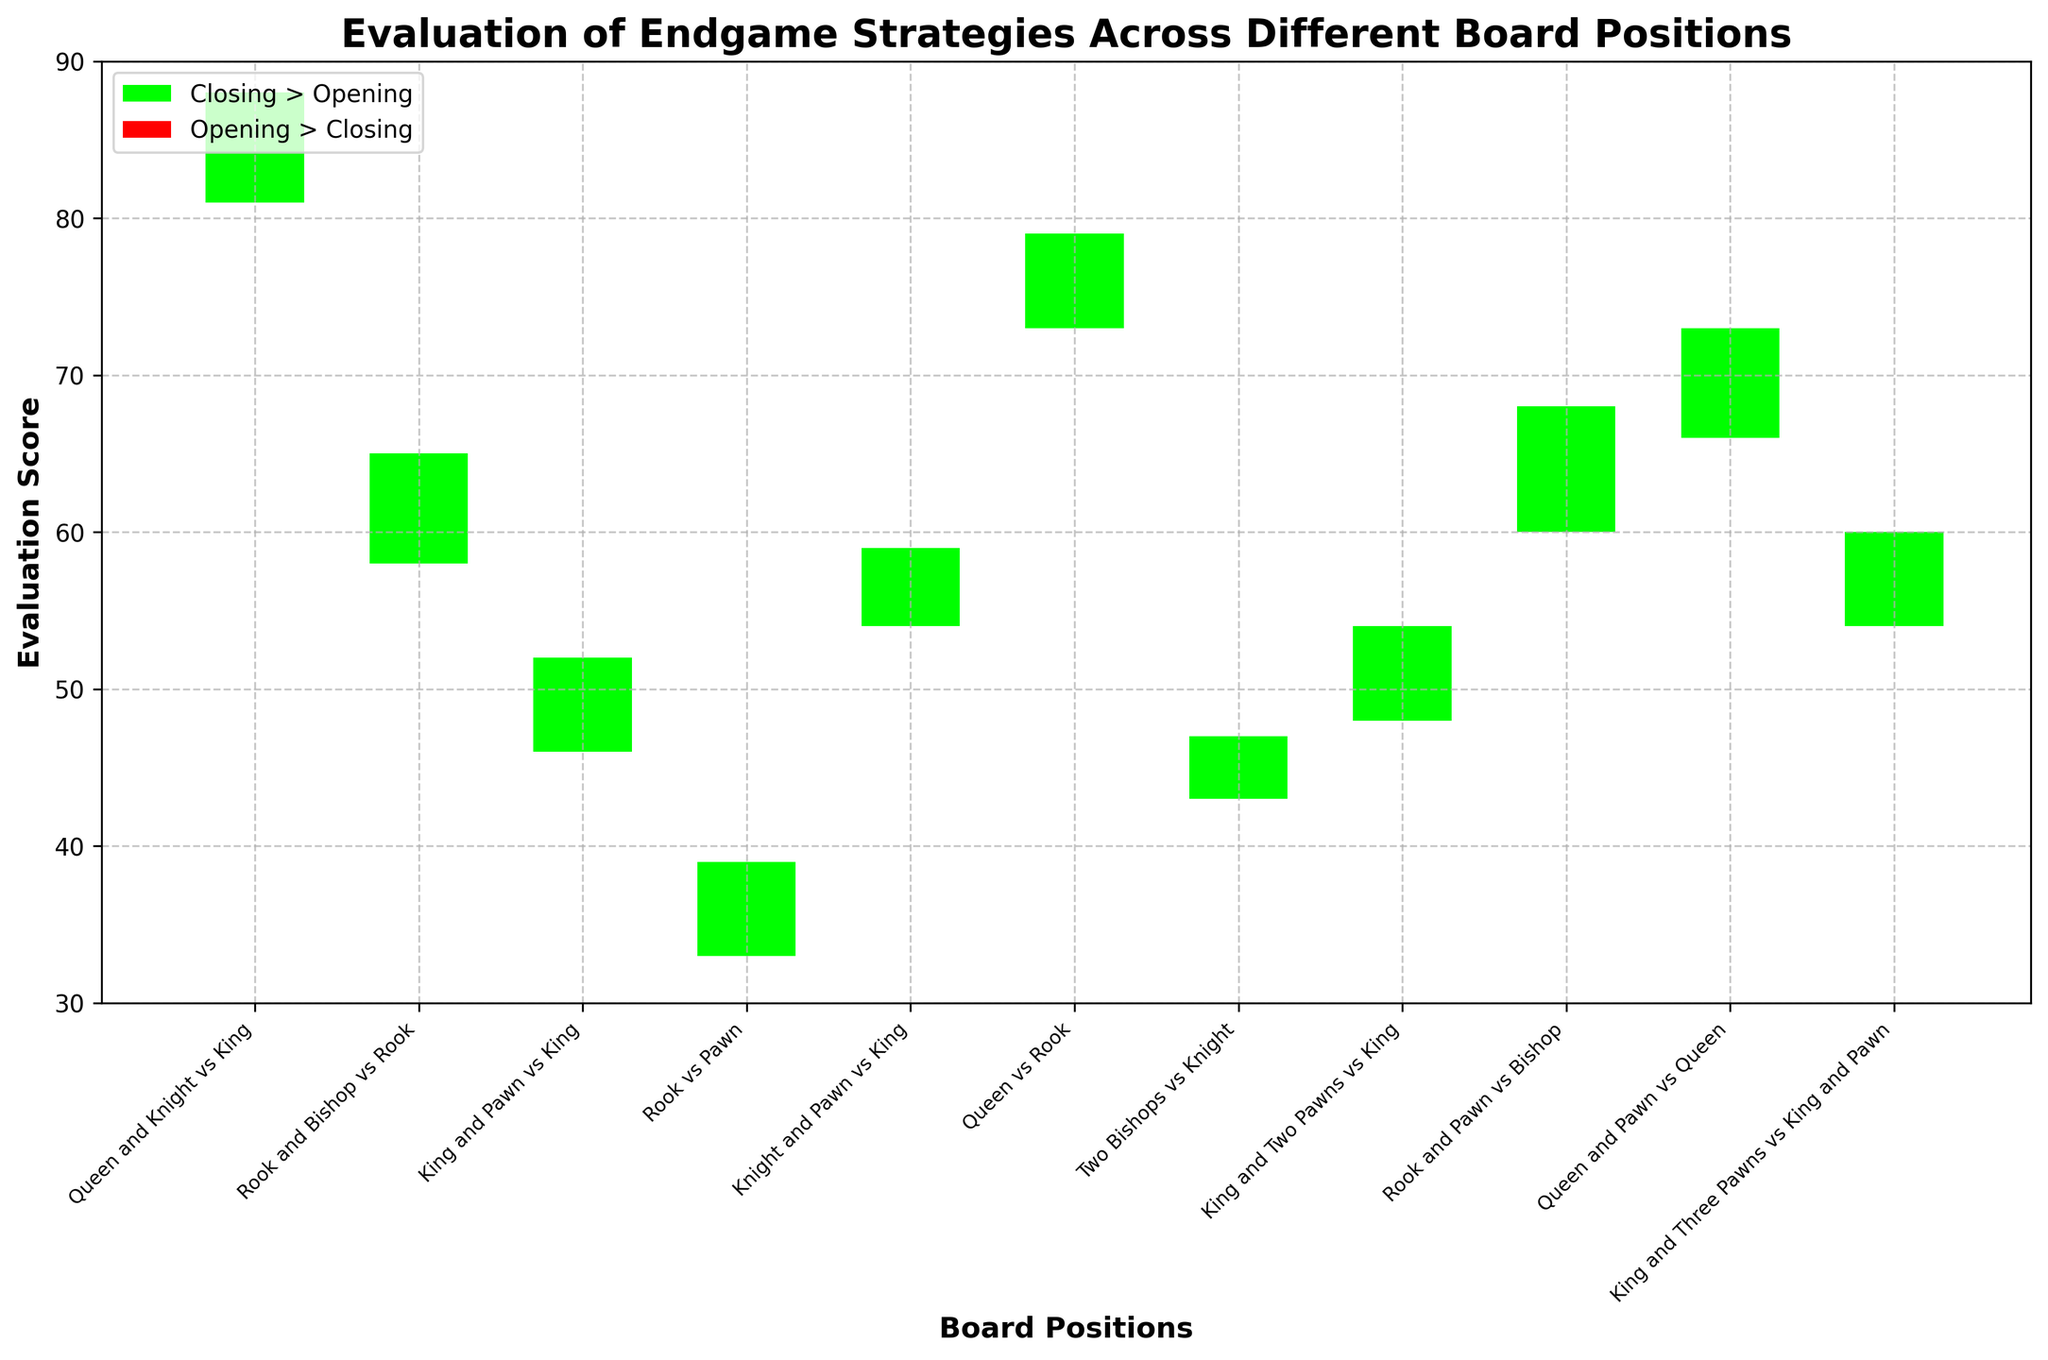Which board position has the highest closing evaluation score? The board position with the highest closing evaluation score is the one with the tallest green candlestick above its opening mark or the highest closing value among all positions.
Answer: Queen and Knight vs King How many board positions have their closing evaluation score higher than their opening evaluation score? To find the number of board positions where the closing evaluation score is higher than the opening, count the number of green candlesticks.
Answer: 8 What is the median of the closing evaluation scores? Order all the closing evaluation scores and find the middle value. The closing scores are [37, 46, 50, 51, 52, 58, 63, 65, 71, 77, 85], the median is the middle value 52.
Answer: 52 Which board position experiences the largest spread between the high and low evaluation scores? Calculate the spread (High - Low) for each position and identify the largest one. Queen and Knight vs King: 88-81=7, Rook and Bishop vs Rook: 65-58=7, King and Pawn vs King: 52-46=6, Rook vs Pawn: 39-33=6, Knight and Pawn vs King: 59-54=5, Queen vs Rook: 79-73=6, Two Bishops vs Knight: 47-43=4, King and Two Pawns vs King: 54-48=6, Rook and Pawn vs Bishop: 68-60=8, Queen and Pawn vs Queen: 73-66=7, King and Three Pawns vs King and Pawn: 60-54=6. Therefore, Rook and Pawn vs Bishop has the largest spread of 8.
Answer: Rook and Pawn vs Bishop Which board position has the lowest low evaluation score? Identify the position with the lowest value under the "Low" column.
Answer: Rook vs Pawn What is the average high evaluation score for all the board positions? Sum all the high values and divide by the number of positions. (88 + 65 + 52 + 39 + 59 + 79 + 47 + 54 + 68 + 73 + 60) / 11.
Answer: 62 Compare the closing scores for Queen and Knight vs King and Queen vs Rook. Which one is higher? Look at the closing evaluation scores for both positions and compare them. Queen and Knight vs King has 85 and Queen vs Rook has 77.
Answer: Queen and Knight vs King For which board position is the opening evaluation score the highest? Identify the position with the highest value under the "Open" column.
Answer: Queen and Knight vs King What are the evaluation scores for the position Rook and Bishop vs Rook? Refer to the corresponding row: High: 65, Low: 58, Open: 62, Close: 63.
Answer: High: 65, Low: 58, Open: 62, Close: 63 